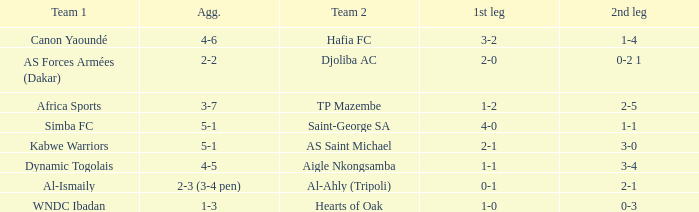What was the 2nd leg result in the match that scored a 2-0 in the 1st leg? 0-2 1. 